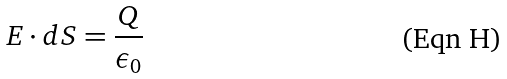<formula> <loc_0><loc_0><loc_500><loc_500>E \cdot d S = \frac { Q } { \epsilon _ { 0 } }</formula> 